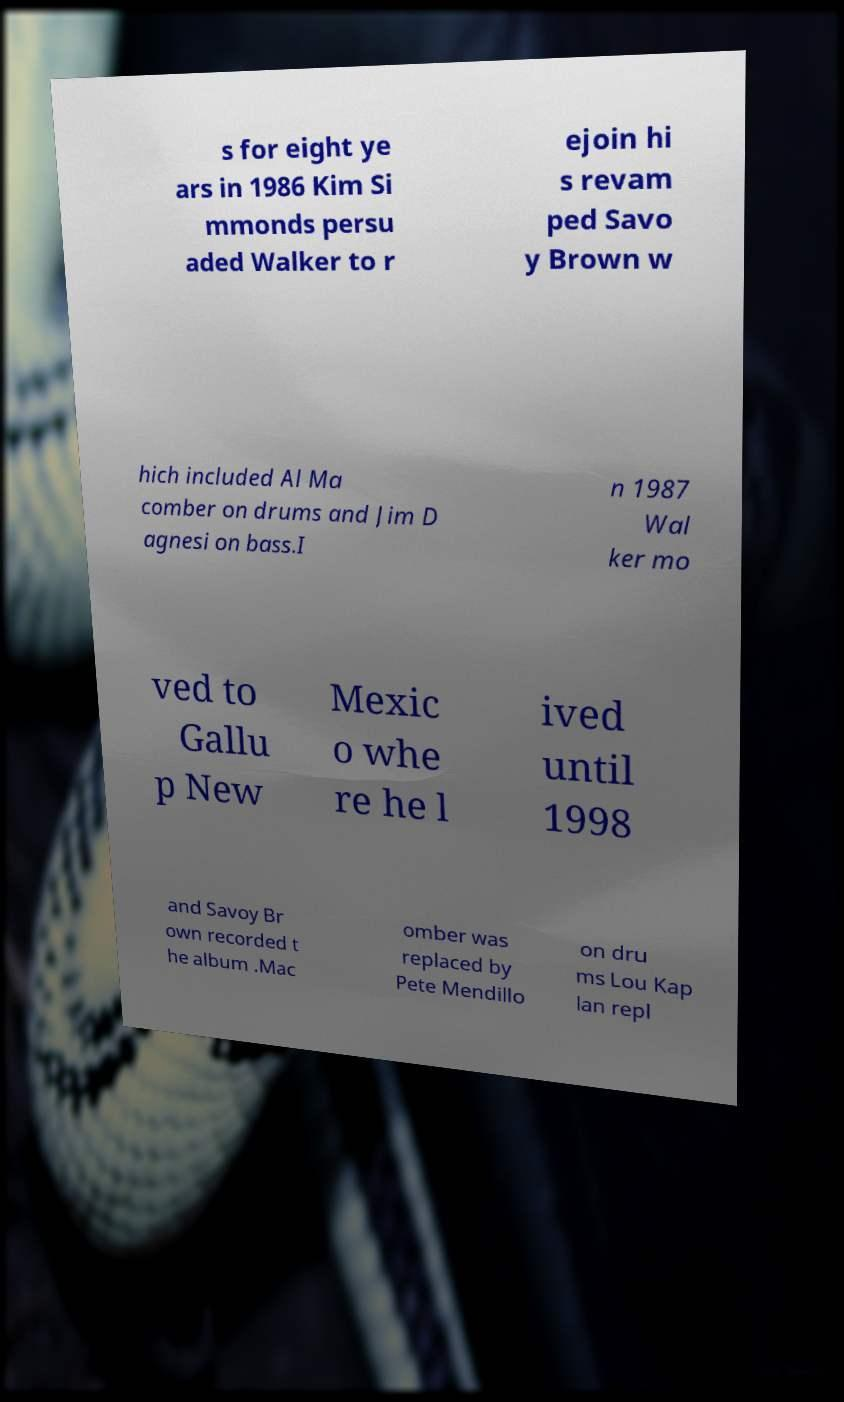Please identify and transcribe the text found in this image. s for eight ye ars in 1986 Kim Si mmonds persu aded Walker to r ejoin hi s revam ped Savo y Brown w hich included Al Ma comber on drums and Jim D agnesi on bass.I n 1987 Wal ker mo ved to Gallu p New Mexic o whe re he l ived until 1998 and Savoy Br own recorded t he album .Mac omber was replaced by Pete Mendillo on dru ms Lou Kap lan repl 